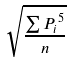Convert formula to latex. <formula><loc_0><loc_0><loc_500><loc_500>\sqrt { \frac { \sum { P _ { i } } ^ { 5 } } { n } }</formula> 